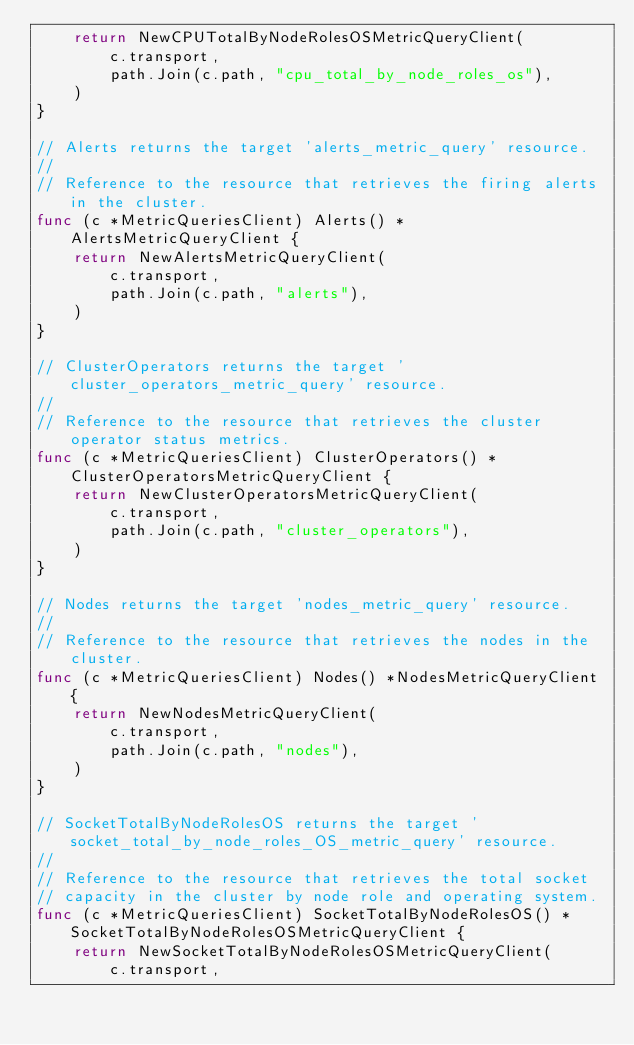Convert code to text. <code><loc_0><loc_0><loc_500><loc_500><_Go_>	return NewCPUTotalByNodeRolesOSMetricQueryClient(
		c.transport,
		path.Join(c.path, "cpu_total_by_node_roles_os"),
	)
}

// Alerts returns the target 'alerts_metric_query' resource.
//
// Reference to the resource that retrieves the firing alerts in the cluster.
func (c *MetricQueriesClient) Alerts() *AlertsMetricQueryClient {
	return NewAlertsMetricQueryClient(
		c.transport,
		path.Join(c.path, "alerts"),
	)
}

// ClusterOperators returns the target 'cluster_operators_metric_query' resource.
//
// Reference to the resource that retrieves the cluster operator status metrics.
func (c *MetricQueriesClient) ClusterOperators() *ClusterOperatorsMetricQueryClient {
	return NewClusterOperatorsMetricQueryClient(
		c.transport,
		path.Join(c.path, "cluster_operators"),
	)
}

// Nodes returns the target 'nodes_metric_query' resource.
//
// Reference to the resource that retrieves the nodes in the cluster.
func (c *MetricQueriesClient) Nodes() *NodesMetricQueryClient {
	return NewNodesMetricQueryClient(
		c.transport,
		path.Join(c.path, "nodes"),
	)
}

// SocketTotalByNodeRolesOS returns the target 'socket_total_by_node_roles_OS_metric_query' resource.
//
// Reference to the resource that retrieves the total socket
// capacity in the cluster by node role and operating system.
func (c *MetricQueriesClient) SocketTotalByNodeRolesOS() *SocketTotalByNodeRolesOSMetricQueryClient {
	return NewSocketTotalByNodeRolesOSMetricQueryClient(
		c.transport,</code> 